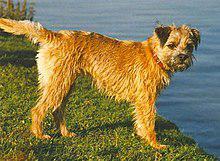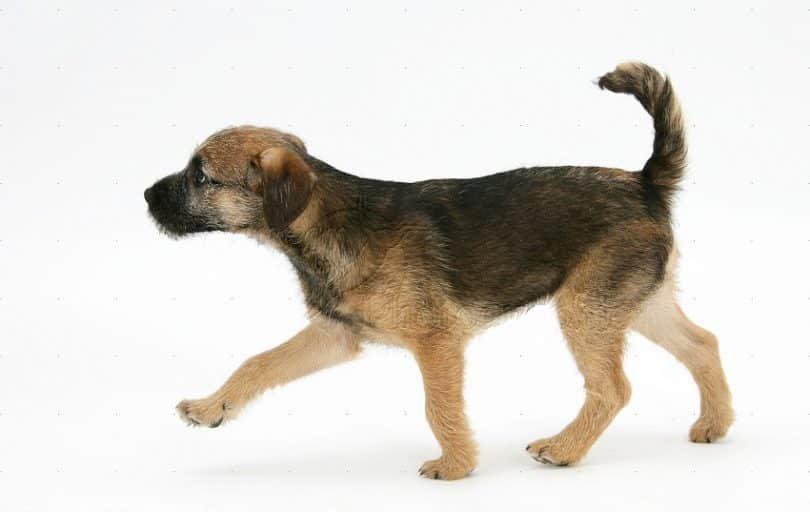The first image is the image on the left, the second image is the image on the right. For the images displayed, is the sentence "The dog on the left image is facing left while the dog on the right image is facing directly towards the camera." factually correct? Answer yes or no. No. 